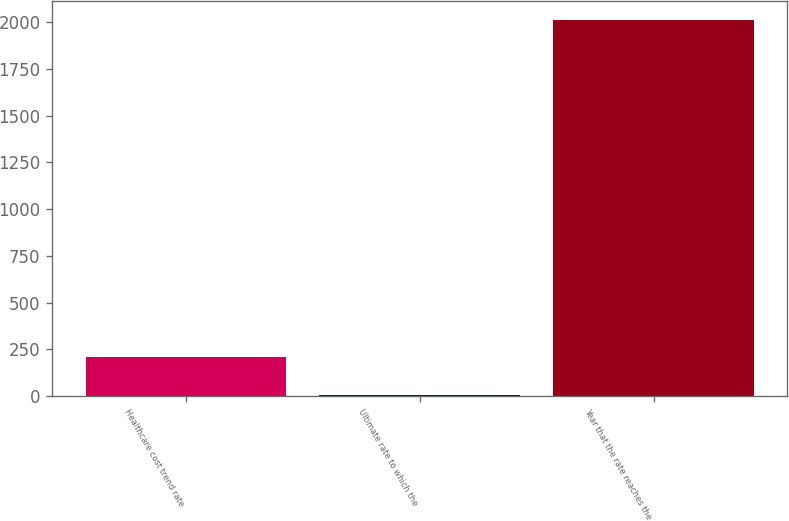Convert chart to OTSL. <chart><loc_0><loc_0><loc_500><loc_500><bar_chart><fcel>Healthcare cost trend rate<fcel>Ultimate rate to which the<fcel>Year that the rate reaches the<nl><fcel>205.8<fcel>5<fcel>2013<nl></chart> 